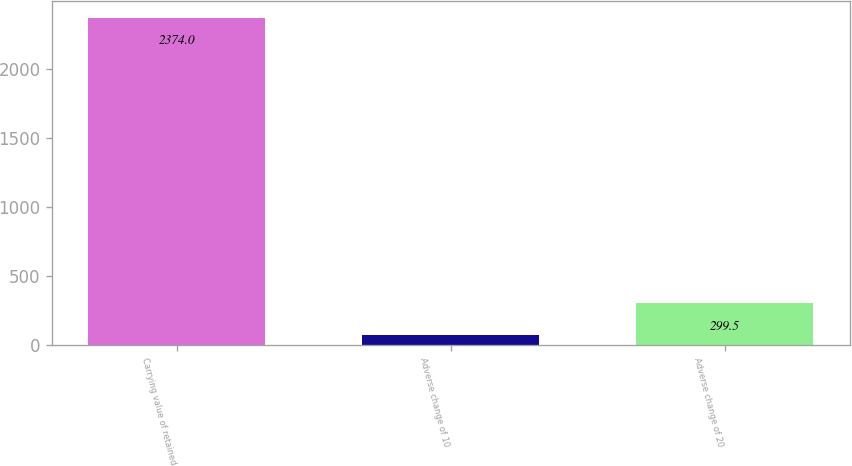Convert chart to OTSL. <chart><loc_0><loc_0><loc_500><loc_500><bar_chart><fcel>Carrying value of retained<fcel>Adverse change of 10<fcel>Adverse change of 20<nl><fcel>2374<fcel>69<fcel>299.5<nl></chart> 